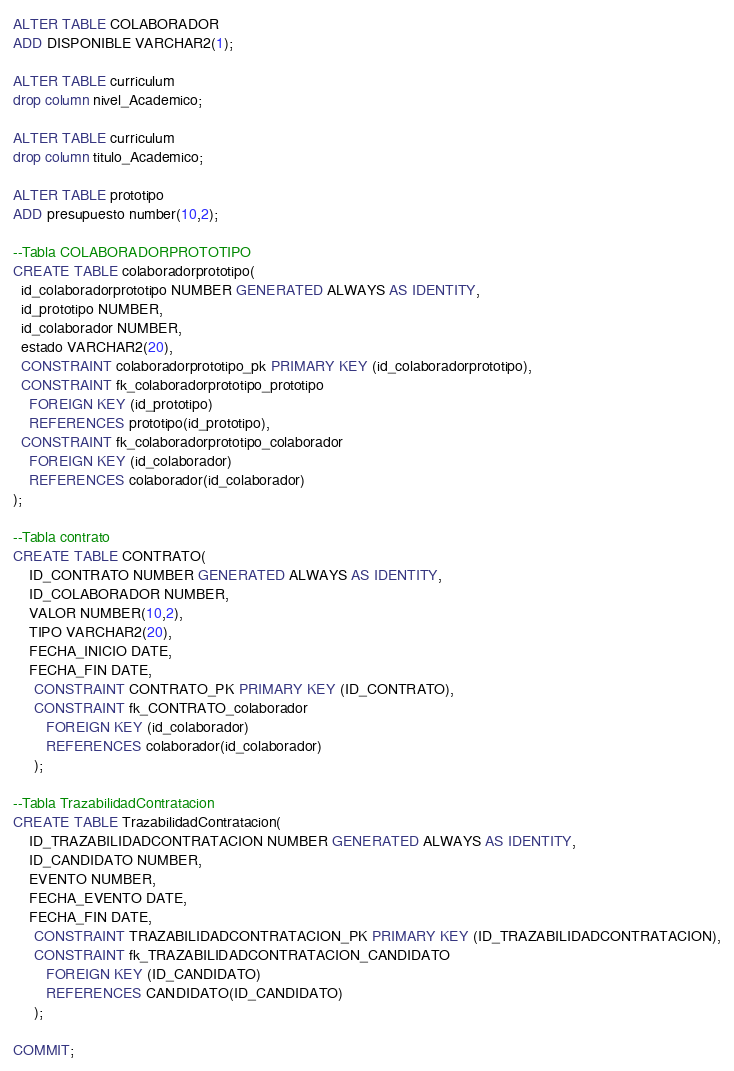Convert code to text. <code><loc_0><loc_0><loc_500><loc_500><_SQL_>ALTER TABLE COLABORADOR 
ADD DISPONIBLE VARCHAR2(1);

ALTER TABLE curriculum
drop column nivel_Academico;

ALTER TABLE curriculum
drop column titulo_Academico;

ALTER TABLE prototipo 
ADD presupuesto number(10,2);

--Tabla COLABORADORPROTOTIPO
CREATE TABLE colaboradorprototipo(
  id_colaboradorprototipo NUMBER GENERATED ALWAYS AS IDENTITY,
  id_prototipo NUMBER,
  id_colaborador NUMBER,
  estado VARCHAR2(20),
  CONSTRAINT colaboradorprototipo_pk PRIMARY KEY (id_colaboradorprototipo),
  CONSTRAINT fk_colaboradorprototipo_prototipo
    FOREIGN KEY (id_prototipo)
    REFERENCES prototipo(id_prototipo),
  CONSTRAINT fk_colaboradorprototipo_colaborador
    FOREIGN KEY (id_colaborador)
    REFERENCES colaborador(id_colaborador)
);

--Tabla contrato
CREATE TABLE CONTRATO(
	ID_CONTRATO NUMBER GENERATED ALWAYS AS IDENTITY,
	ID_COLABORADOR NUMBER, 
	VALOR NUMBER(10,2), 
	TIPO VARCHAR2(20), 
	FECHA_INICIO DATE, 
	FECHA_FIN DATE, 
	 CONSTRAINT CONTRATO_PK PRIMARY KEY (ID_CONTRATO),
	 CONSTRAINT fk_CONTRATO_colaborador
		FOREIGN KEY (id_colaborador)
		REFERENCES colaborador(id_colaborador)
	 );

--Tabla TrazabilidadContratacion
CREATE TABLE TrazabilidadContratacion(
	ID_TRAZABILIDADCONTRATACION NUMBER GENERATED ALWAYS AS IDENTITY,
	ID_CANDIDATO NUMBER, 
	EVENTO NUMBER,
	FECHA_EVENTO DATE, 
	FECHA_FIN DATE, 
	 CONSTRAINT TRAZABILIDADCONTRATACION_PK PRIMARY KEY (ID_TRAZABILIDADCONTRATACION),
	 CONSTRAINT fk_TRAZABILIDADCONTRATACION_CANDIDATO
		FOREIGN KEY (ID_CANDIDATO)
		REFERENCES CANDIDATO(ID_CANDIDATO)
	 );
	 
COMMIT;</code> 